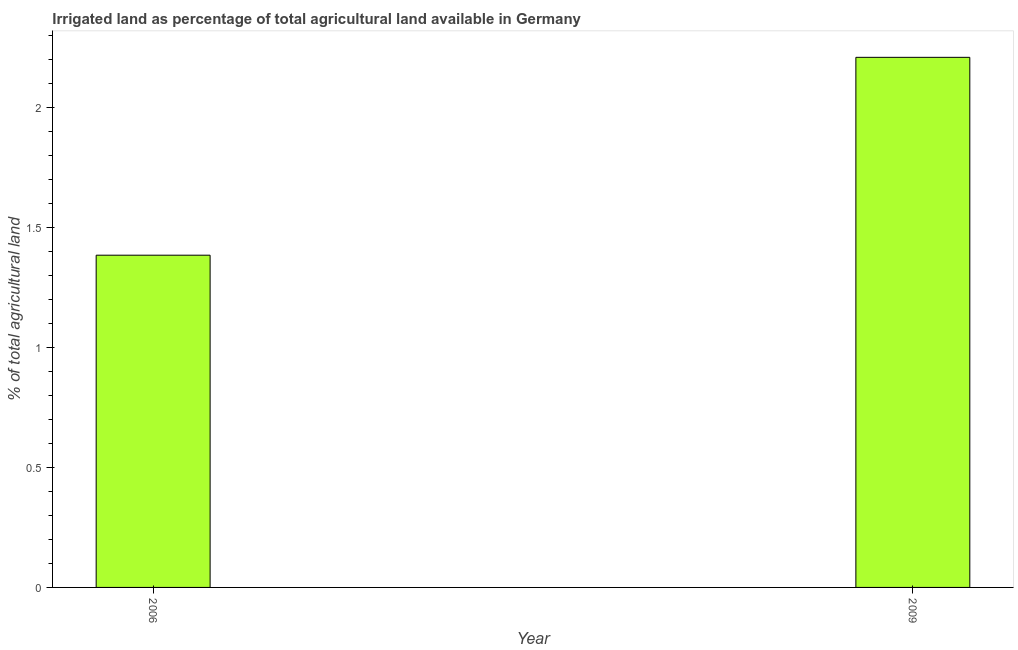Does the graph contain any zero values?
Give a very brief answer. No. What is the title of the graph?
Your answer should be very brief. Irrigated land as percentage of total agricultural land available in Germany. What is the label or title of the X-axis?
Give a very brief answer. Year. What is the label or title of the Y-axis?
Keep it short and to the point. % of total agricultural land. What is the percentage of agricultural irrigated land in 2006?
Make the answer very short. 1.38. Across all years, what is the maximum percentage of agricultural irrigated land?
Your answer should be very brief. 2.21. Across all years, what is the minimum percentage of agricultural irrigated land?
Your response must be concise. 1.38. In which year was the percentage of agricultural irrigated land maximum?
Your answer should be compact. 2009. What is the sum of the percentage of agricultural irrigated land?
Keep it short and to the point. 3.59. What is the difference between the percentage of agricultural irrigated land in 2006 and 2009?
Offer a terse response. -0.82. What is the average percentage of agricultural irrigated land per year?
Provide a succinct answer. 1.8. What is the median percentage of agricultural irrigated land?
Your response must be concise. 1.8. In how many years, is the percentage of agricultural irrigated land greater than 0.7 %?
Make the answer very short. 2. Do a majority of the years between 2009 and 2006 (inclusive) have percentage of agricultural irrigated land greater than 0.6 %?
Your answer should be compact. No. What is the ratio of the percentage of agricultural irrigated land in 2006 to that in 2009?
Keep it short and to the point. 0.63. Is the percentage of agricultural irrigated land in 2006 less than that in 2009?
Your answer should be compact. Yes. Are all the bars in the graph horizontal?
Give a very brief answer. No. How many years are there in the graph?
Your response must be concise. 2. What is the % of total agricultural land in 2006?
Keep it short and to the point. 1.38. What is the % of total agricultural land of 2009?
Ensure brevity in your answer.  2.21. What is the difference between the % of total agricultural land in 2006 and 2009?
Provide a short and direct response. -0.82. What is the ratio of the % of total agricultural land in 2006 to that in 2009?
Your answer should be compact. 0.63. 